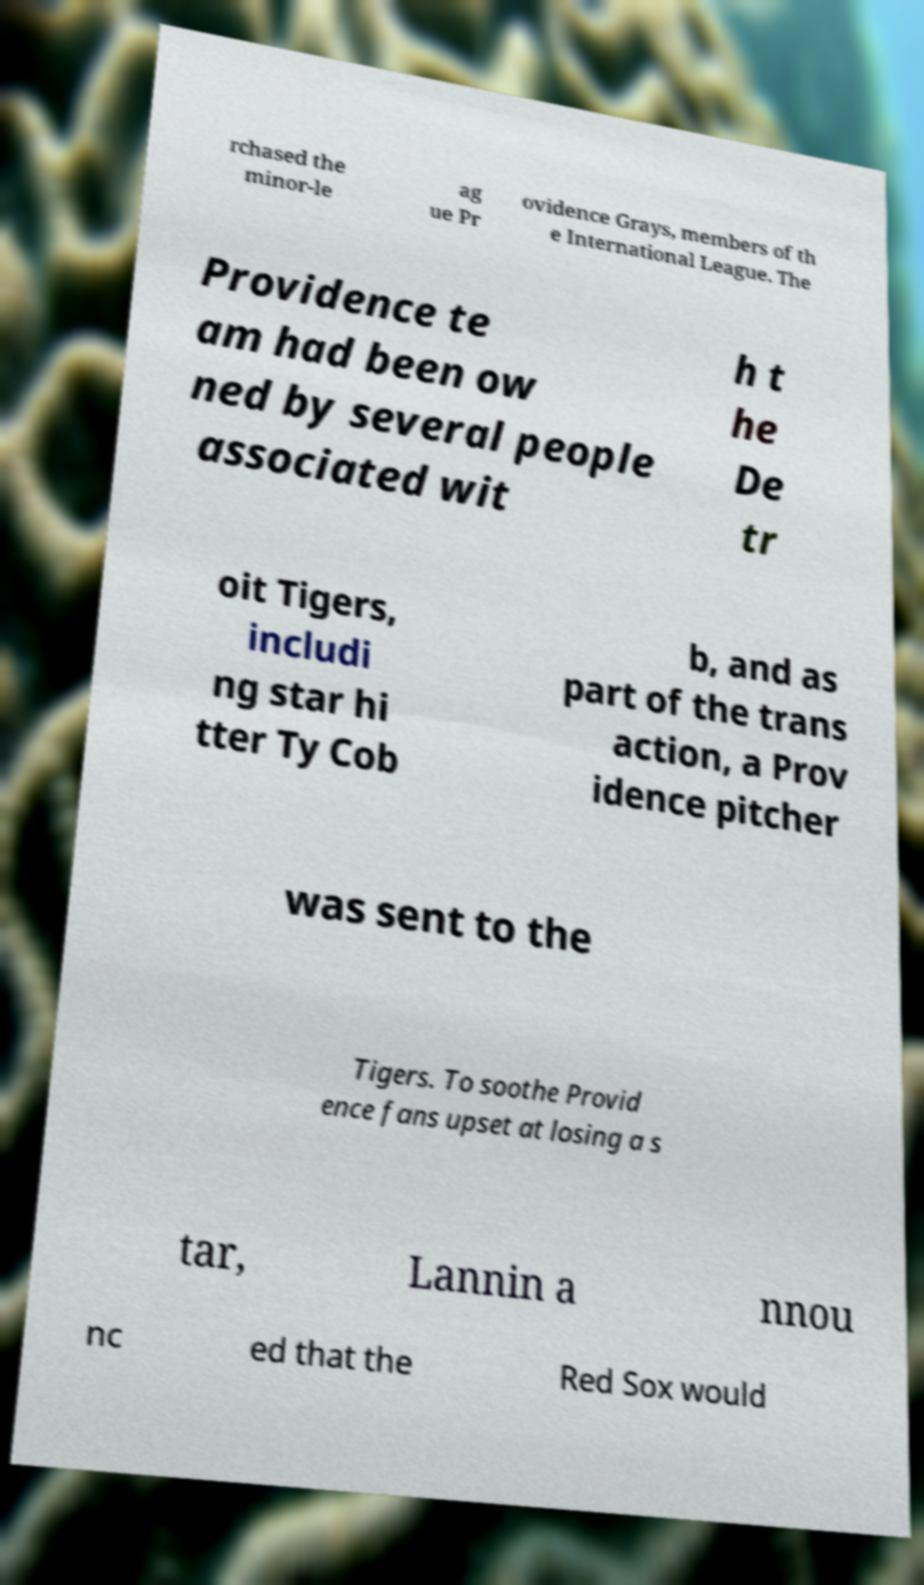Please identify and transcribe the text found in this image. rchased the minor-le ag ue Pr ovidence Grays, members of th e International League. The Providence te am had been ow ned by several people associated wit h t he De tr oit Tigers, includi ng star hi tter Ty Cob b, and as part of the trans action, a Prov idence pitcher was sent to the Tigers. To soothe Provid ence fans upset at losing a s tar, Lannin a nnou nc ed that the Red Sox would 